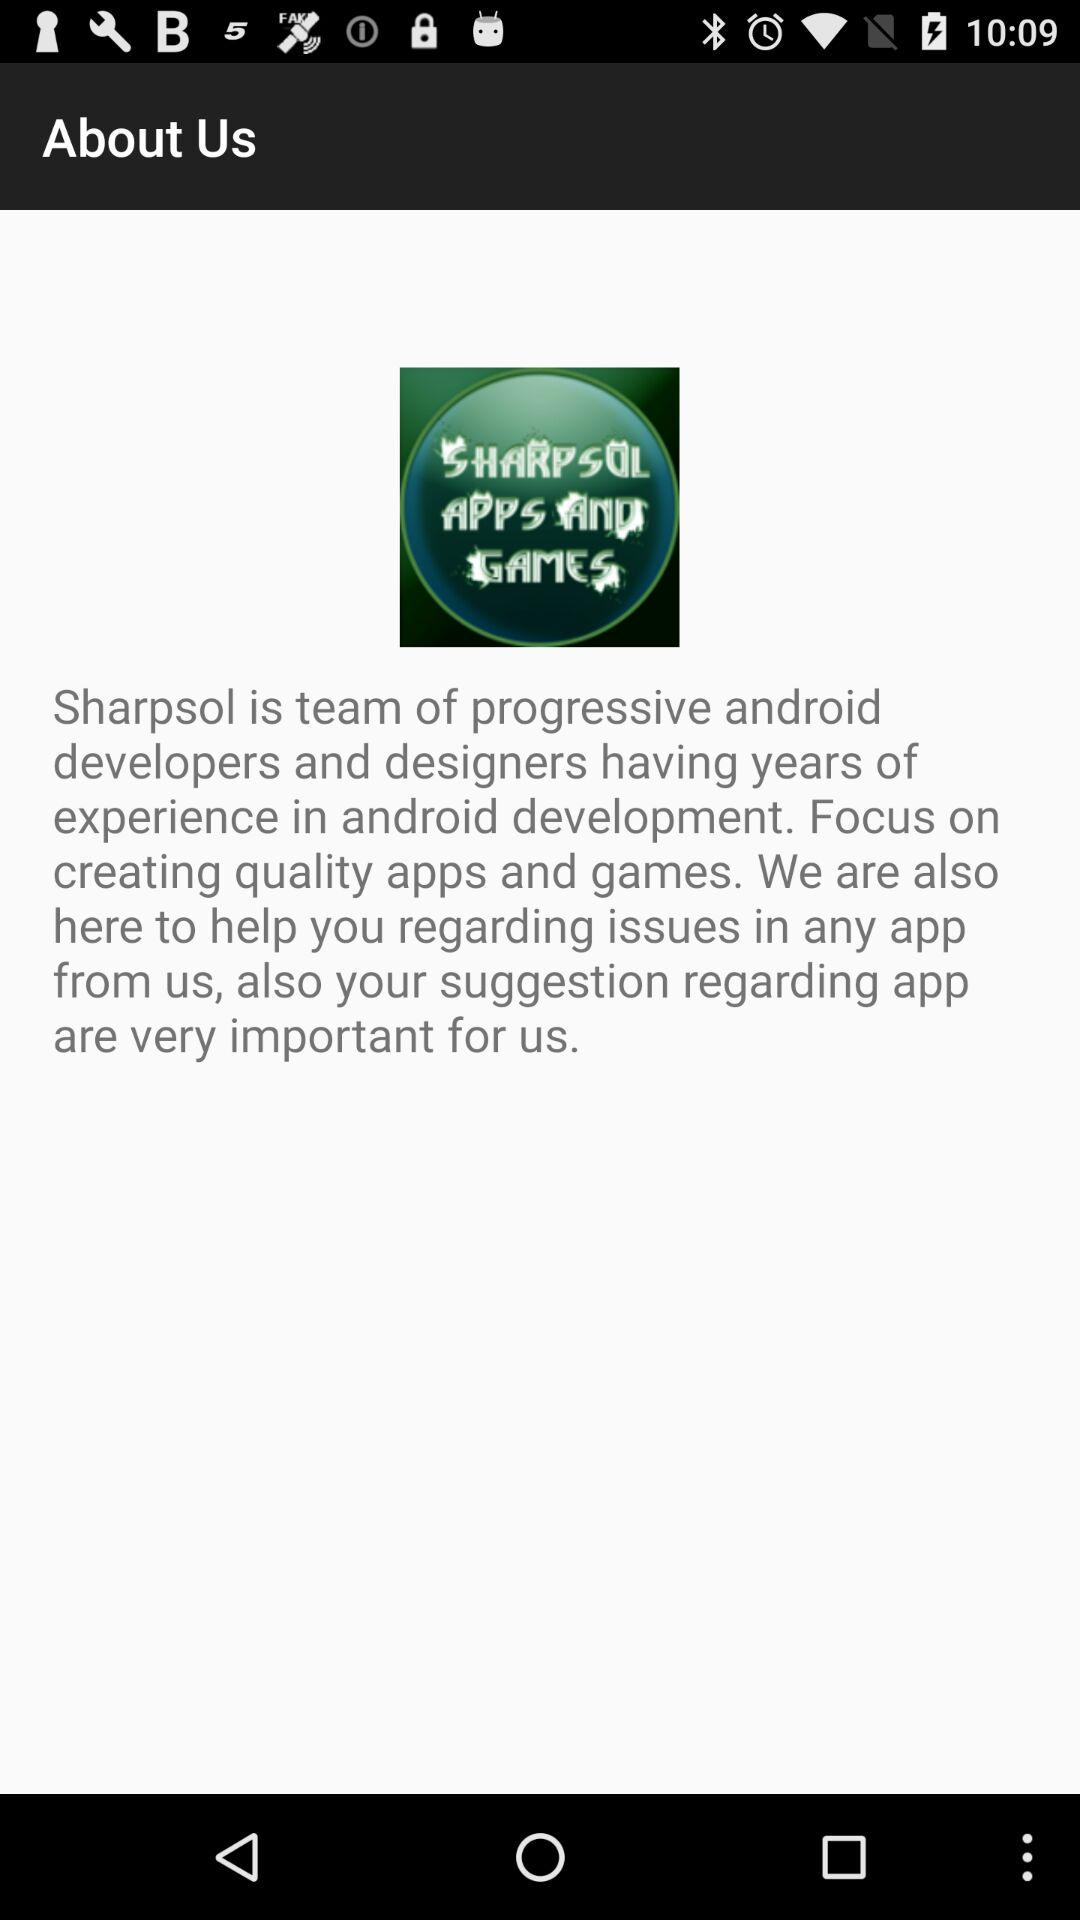What is the developer name? The developer name is Sharpsol. 